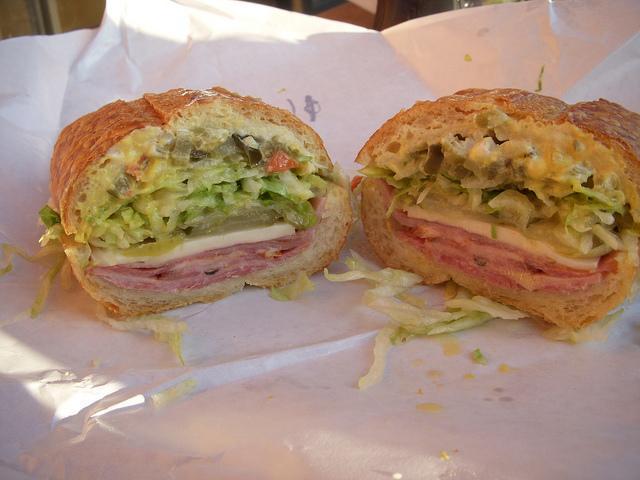How many pieces of sandwich are there?
Give a very brief answer. 2. How many sandwiches are there?
Give a very brief answer. 2. How many elephants can you see it's trunk?
Give a very brief answer. 0. 